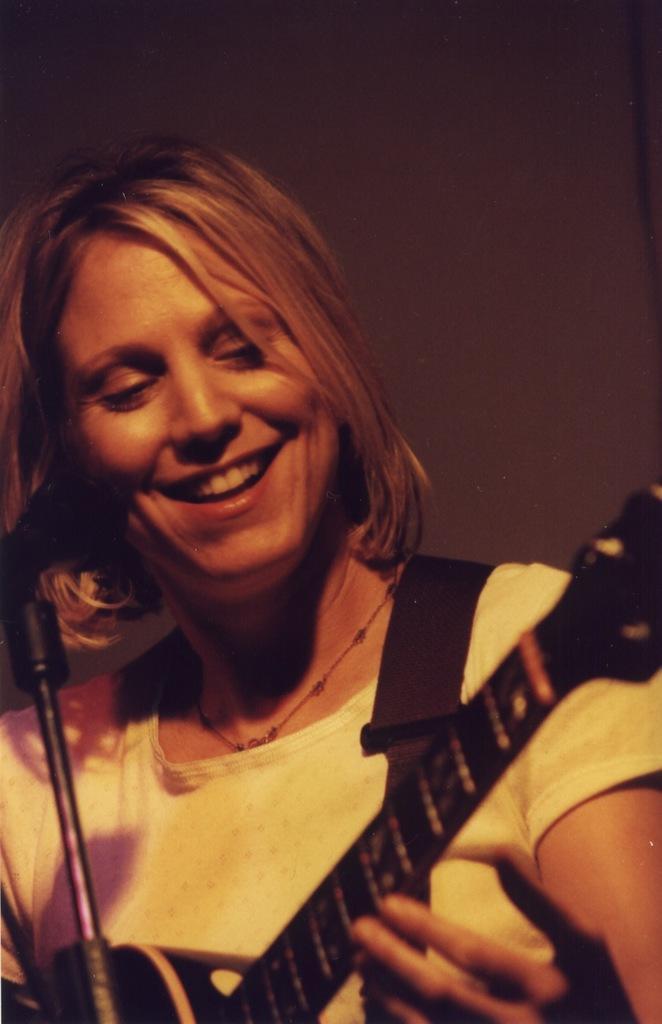Describe this image in one or two sentences. In this image there is one woman who is smiling, and she is holding a guitar. On the background of the image there is one wall. 